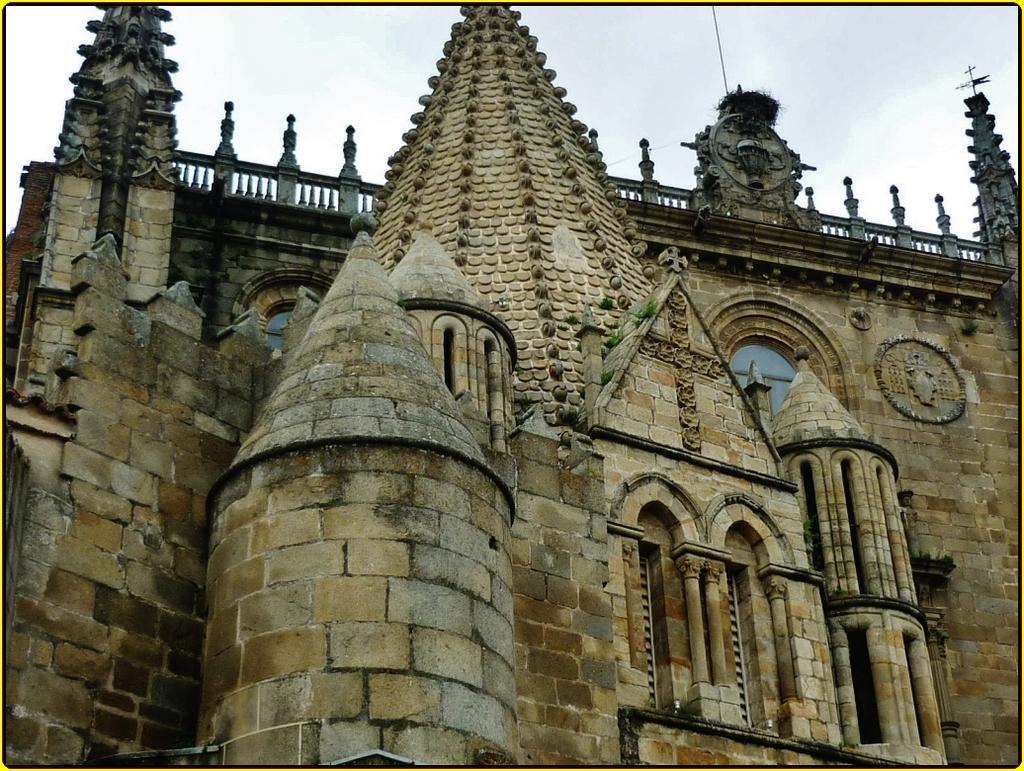Can you describe this image briefly? In this image I can see a building which is cream, brown and black in color and in the background I can see the sky. 